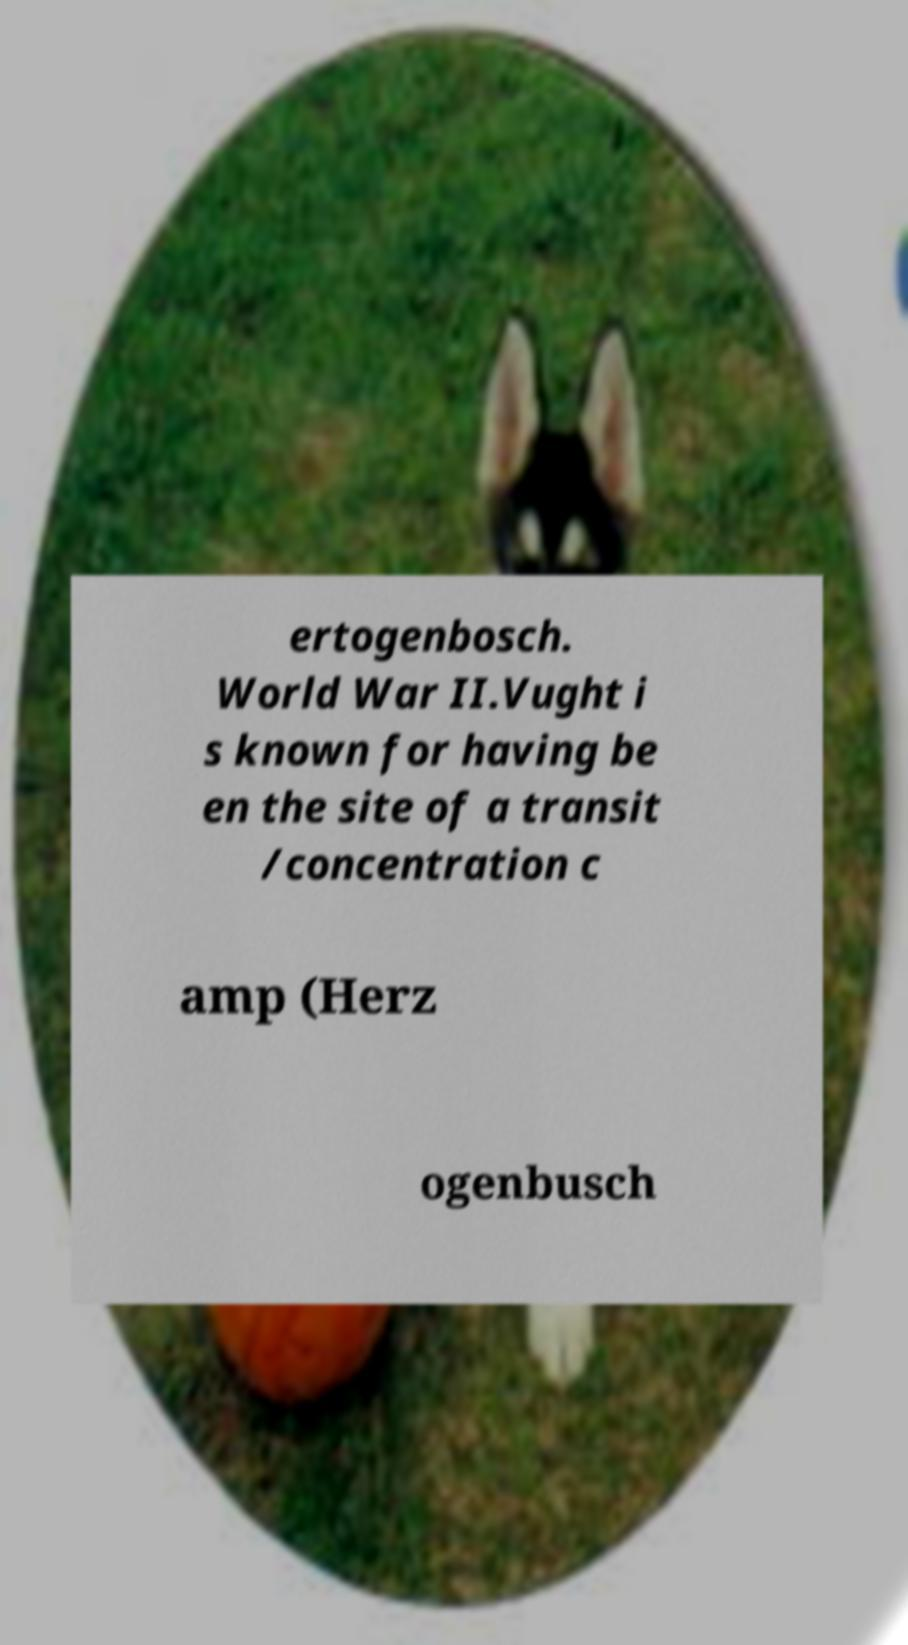Can you accurately transcribe the text from the provided image for me? ertogenbosch. World War II.Vught i s known for having be en the site of a transit /concentration c amp (Herz ogenbusch 